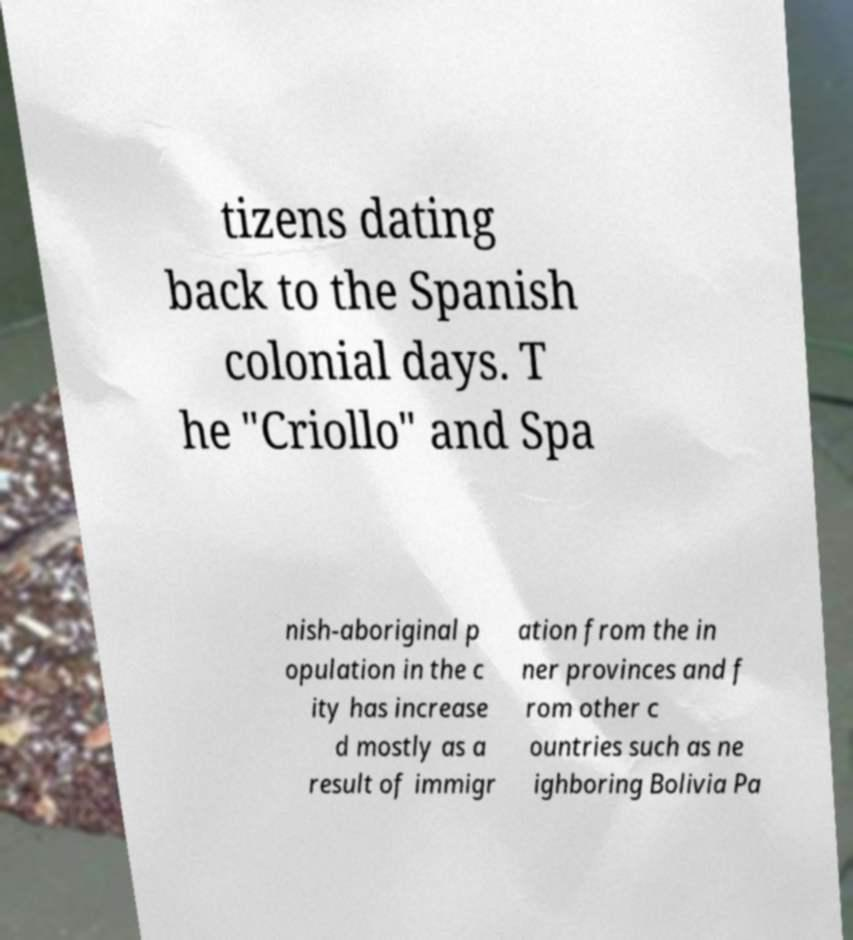For documentation purposes, I need the text within this image transcribed. Could you provide that? tizens dating back to the Spanish colonial days. T he "Criollo" and Spa nish-aboriginal p opulation in the c ity has increase d mostly as a result of immigr ation from the in ner provinces and f rom other c ountries such as ne ighboring Bolivia Pa 